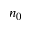<formula> <loc_0><loc_0><loc_500><loc_500>n _ { 0 }</formula> 